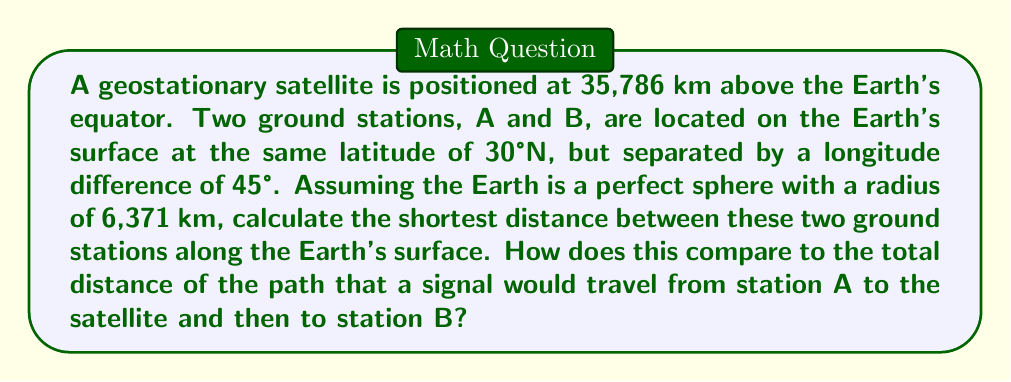Solve this math problem. Let's approach this problem step-by-step:

1) First, we need to calculate the shortest distance between A and B along the Earth's surface. This is a great circle distance.

2) The formula for great circle distance is:
   $$d = R \cdot \arccos(\sin(\phi_1)\sin(\phi_2) + \cos(\phi_1)\cos(\phi_2)\cos(\Delta\lambda))$$
   where R is the Earth's radius, $\phi_1$ and $\phi_2$ are the latitudes, and $\Delta\lambda$ is the difference in longitude.

3) In our case:
   $R = 6371$ km
   $\phi_1 = \phi_2 = 30°$ (converted to radians: $\frac{\pi}{6}$)
   $\Delta\lambda = 45°$ (converted to radians: $\frac{\pi}{4}$)

4) Plugging these into the formula:
   $$d = 6371 \cdot \arccos(\sin(\frac{\pi}{6})\sin(\frac{\pi}{6}) + \cos(\frac{\pi}{6})\cos(\frac{\pi}{6})\cos(\frac{\pi}{4}))$$
   $$= 6371 \cdot \arccos(0.25 + 0.75 \cdot 0.7071)$$
   $$= 6371 \cdot \arccos(0.7803)$$
   $$= 6371 \cdot 0.6847 = 4362.5 \text{ km}$$

5) Now, for the satellite path, we need to calculate the distance from each ground station to the satellite.

6) The distance from the center of the Earth to the satellite is:
   $$r_s = 6371 + 35786 = 42157 \text{ km}$$

7) We can use the law of cosines to find the distance from a ground station to the satellite:
   $$d_{gs}^2 = r_s^2 + R^2 - 2r_sR\cos(\frac{\pi}{2} - \frac{\pi}{6})$$
   $$= 42157^2 + 6371^2 - 2 \cdot 42157 \cdot 6371 \cdot \sin(\frac{\pi}{6})$$
   $$= 37624.3 \text{ km}$$

8) The total path through the satellite is:
   $$2 \cdot 37624.3 = 75248.6 \text{ km}$$

9) The ratio of the satellite path to the great circle path is:
   $$\frac{75248.6}{4362.5} \approx 17.25$$
Answer: Great circle distance: 4362.5 km. Satellite path: 75248.6 km. Ratio: 17.25. 